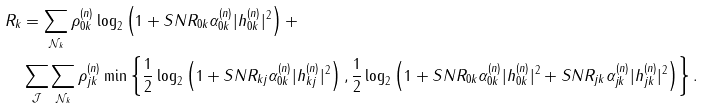<formula> <loc_0><loc_0><loc_500><loc_500>R _ { k } & = \sum _ { \mathcal { N } _ { k } } \rho _ { 0 k } ^ { ( n ) } \log _ { 2 } \left ( 1 + S N R _ { 0 k } \alpha _ { 0 k } ^ { ( n ) } | { h _ { 0 k } ^ { ( n ) } } | ^ { 2 } \right ) + \\ & \sum _ { \mathcal { J } } \sum _ { \mathcal { N } _ { k } } \rho _ { j k } ^ { ( n ) } \min \left \{ \frac { 1 } { 2 } \log _ { 2 } \left ( 1 + S N R _ { k j } \alpha _ { 0 k } ^ { ( n ) } | { h _ { k j } ^ { ( n ) } } | ^ { 2 } \right ) , \frac { 1 } { 2 } \log _ { 2 } \left ( 1 + S N R _ { 0 k } \alpha _ { 0 k } ^ { ( n ) } | { h _ { 0 k } ^ { ( n ) } } | ^ { 2 } + S N R _ { j k } \alpha _ { j k } ^ { ( n ) } | { h _ { j k } ^ { ( n ) } } | ^ { 2 } \right ) \right \} .</formula> 